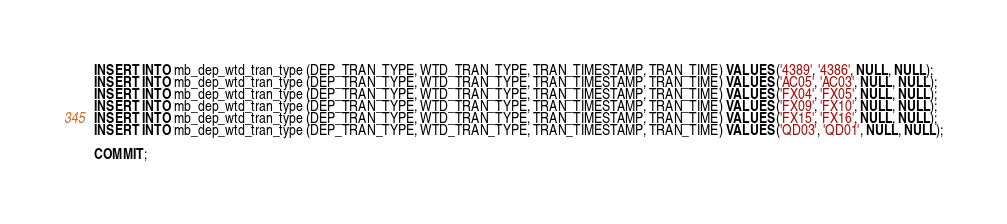Convert code to text. <code><loc_0><loc_0><loc_500><loc_500><_SQL_>INSERT INTO mb_dep_wtd_tran_type (DEP_TRAN_TYPE, WTD_TRAN_TYPE, TRAN_TIMESTAMP, TRAN_TIME) VALUES ('4389', '4386', NULL, NULL);
INSERT INTO mb_dep_wtd_tran_type (DEP_TRAN_TYPE, WTD_TRAN_TYPE, TRAN_TIMESTAMP, TRAN_TIME) VALUES ('AC05', 'AC03', NULL, NULL);
INSERT INTO mb_dep_wtd_tran_type (DEP_TRAN_TYPE, WTD_TRAN_TYPE, TRAN_TIMESTAMP, TRAN_TIME) VALUES ('FX04', 'FX05', NULL, NULL);
INSERT INTO mb_dep_wtd_tran_type (DEP_TRAN_TYPE, WTD_TRAN_TYPE, TRAN_TIMESTAMP, TRAN_TIME) VALUES ('FX09', 'FX10', NULL, NULL);
INSERT INTO mb_dep_wtd_tran_type (DEP_TRAN_TYPE, WTD_TRAN_TYPE, TRAN_TIMESTAMP, TRAN_TIME) VALUES ('FX15', 'FX16', NULL, NULL);
INSERT INTO mb_dep_wtd_tran_type (DEP_TRAN_TYPE, WTD_TRAN_TYPE, TRAN_TIMESTAMP, TRAN_TIME) VALUES ('QD03', 'QD01', NULL, NULL);

COMMIT;
</code> 